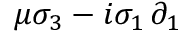<formula> <loc_0><loc_0><loc_500><loc_500>\mu \sigma _ { 3 } - i \sigma _ { 1 } \, \partial _ { 1 }</formula> 